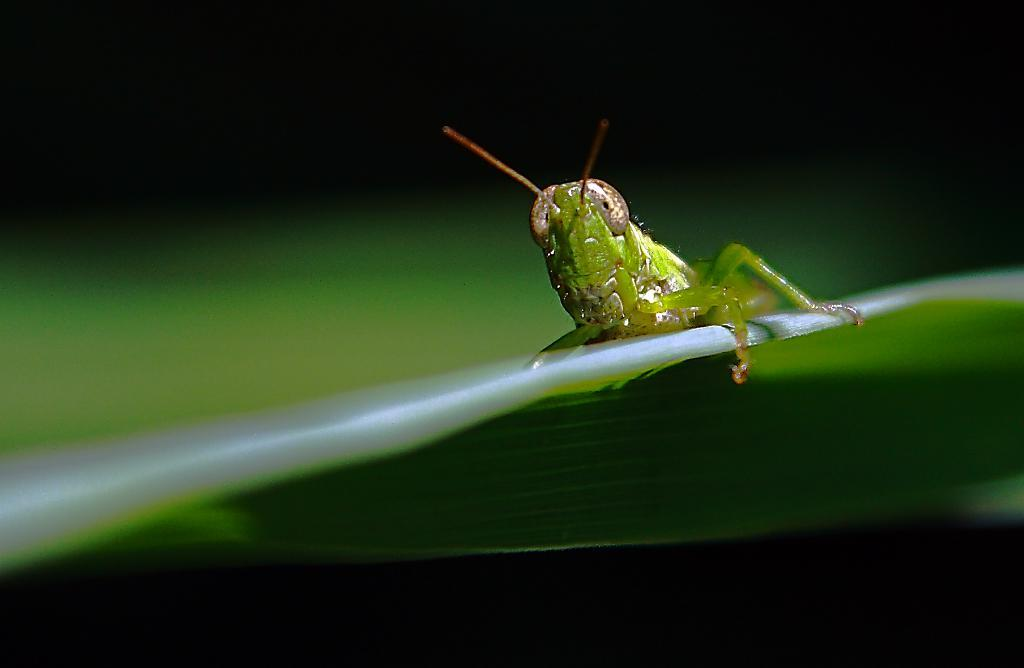What is the main subject in the foreground of the image? There is an insect on a leaf in the foreground of the image. What can be observed about the background of the image? The background of the image is dark in color. Based on the dark background, can we infer the time of day when the image was taken? The image may have been taken during the night, as the dark background suggests a lack of sunlight. What type of shade is provided by the insect in the image? There is no shade provided by the insect in the image, as insects do not typically offer shade. 